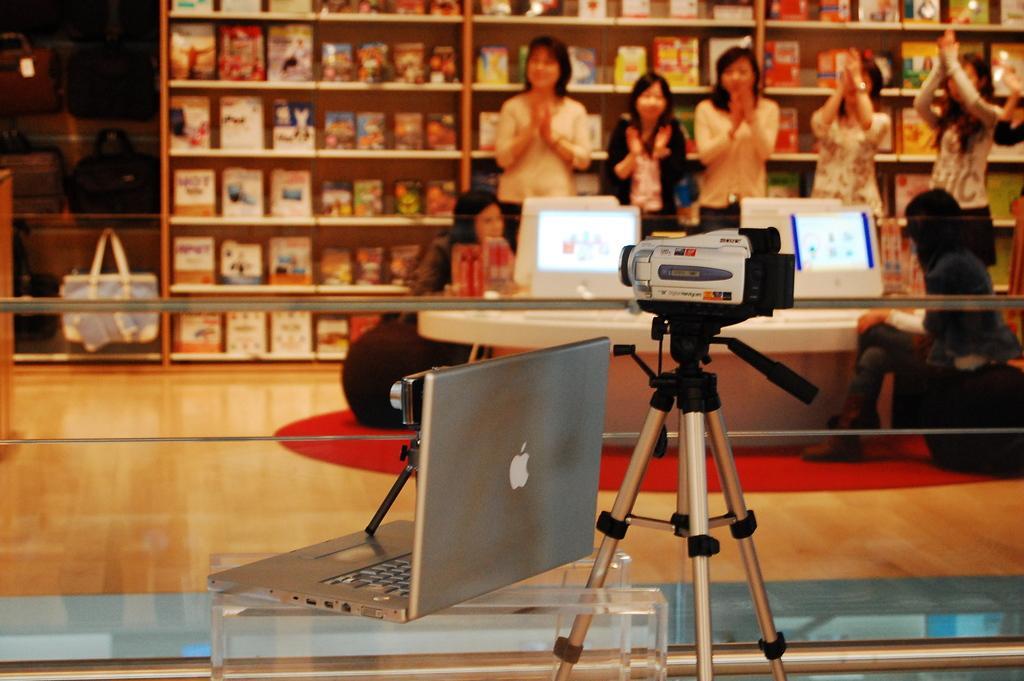In one or two sentences, can you explain what this image depicts? In the image we can see there are many people wearing clothes, they are standing and some of them are sitting. This is a video camera, stand, laptop, logo, wooden floor, shelf, boxes on the shelf and a hand bag. 